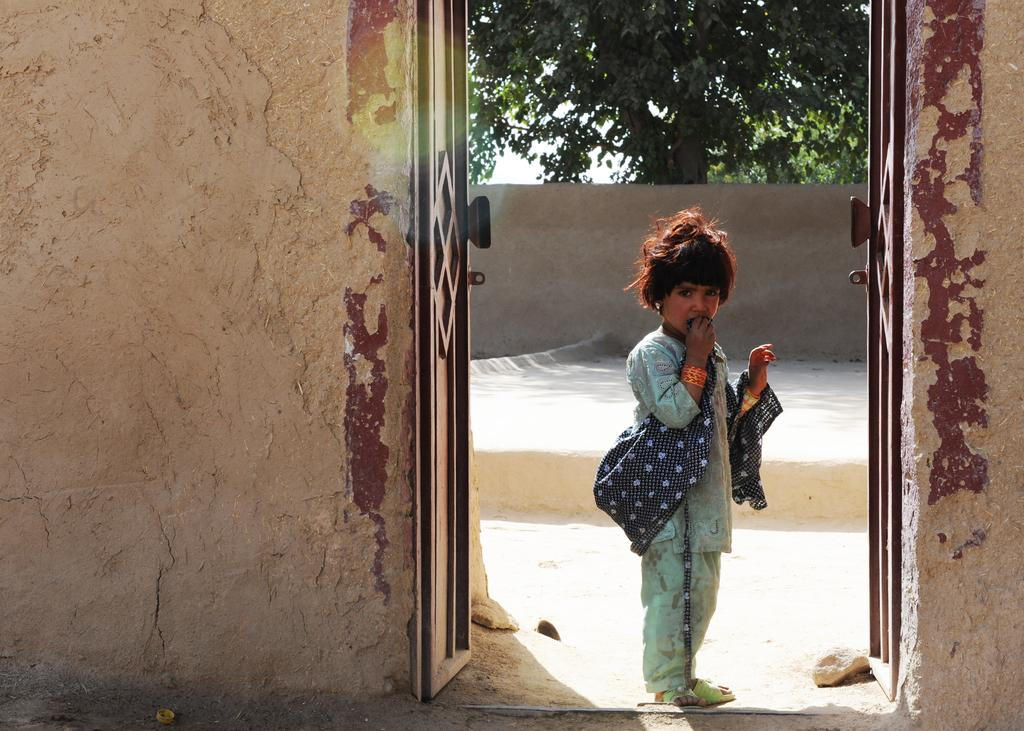What is the child doing in the image? The child is standing on the ground in the image. What structure is present in the image? There is a door in the image. What can be seen on the sides of the door? The walls are visible in the image. What type of natural environment is visible in the image? There are trees in the image, indicating a natural environment. What is visible above the trees? The sky is visible in the image. What type of protest is happening in the image? There is no protest present in the image. Can you describe the snake that is slithering through the trees? There is no snake present in the image; it only features a child, a door, walls, trees, and the sky. 